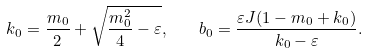Convert formula to latex. <formula><loc_0><loc_0><loc_500><loc_500>k _ { 0 } = \frac { m _ { 0 } } { 2 } + \sqrt { \frac { m ^ { 2 } _ { 0 } } { 4 } - \varepsilon } , \quad b _ { 0 } = \frac { \varepsilon J ( 1 - m _ { 0 } + k _ { 0 } ) } { k _ { 0 } - \varepsilon } .</formula> 